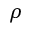Convert formula to latex. <formula><loc_0><loc_0><loc_500><loc_500>\rho</formula> 